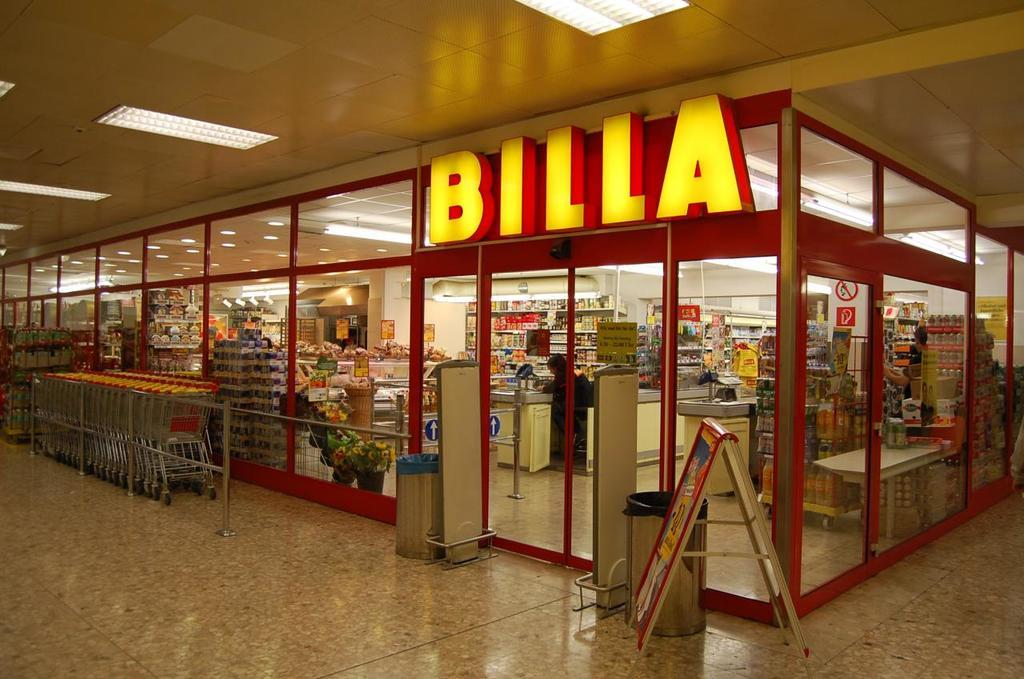<image>
Write a terse but informative summary of the picture. A Billa store has carts neatly lined up outside. 